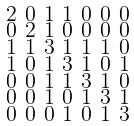Convert formula to latex. <formula><loc_0><loc_0><loc_500><loc_500>\begin{smallmatrix} 2 & 0 & 1 & 1 & 0 & 0 & 0 \\ 0 & 2 & 1 & 0 & 0 & 0 & 0 \\ 1 & 1 & 3 & 1 & 1 & 1 & 0 \\ 1 & 0 & 1 & 3 & 1 & 0 & 1 \\ 0 & 0 & 1 & 1 & 3 & 1 & 0 \\ 0 & 0 & 1 & 0 & 1 & 3 & 1 \\ 0 & 0 & 0 & 1 & 0 & 1 & 3 \end{smallmatrix}</formula> 